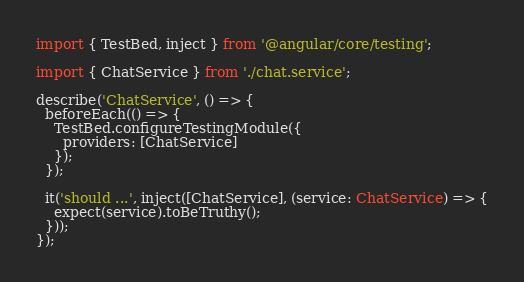<code> <loc_0><loc_0><loc_500><loc_500><_TypeScript_>import { TestBed, inject } from '@angular/core/testing';

import { ChatService } from './chat.service';

describe('ChatService', () => {
  beforeEach(() => {
    TestBed.configureTestingModule({
      providers: [ChatService]
    });
  });

  it('should ...', inject([ChatService], (service: ChatService) => {
    expect(service).toBeTruthy();
  }));
});
</code> 